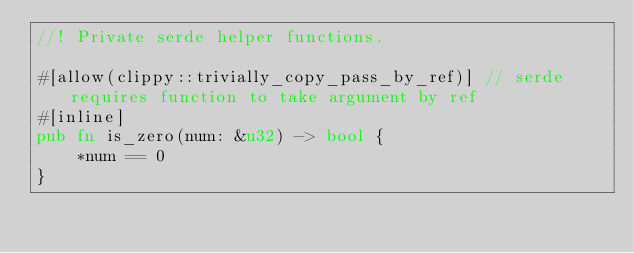<code> <loc_0><loc_0><loc_500><loc_500><_Rust_>//! Private serde helper functions.

#[allow(clippy::trivially_copy_pass_by_ref)] // serde requires function to take argument by ref
#[inline]
pub fn is_zero(num: &u32) -> bool {
    *num == 0
}
</code> 